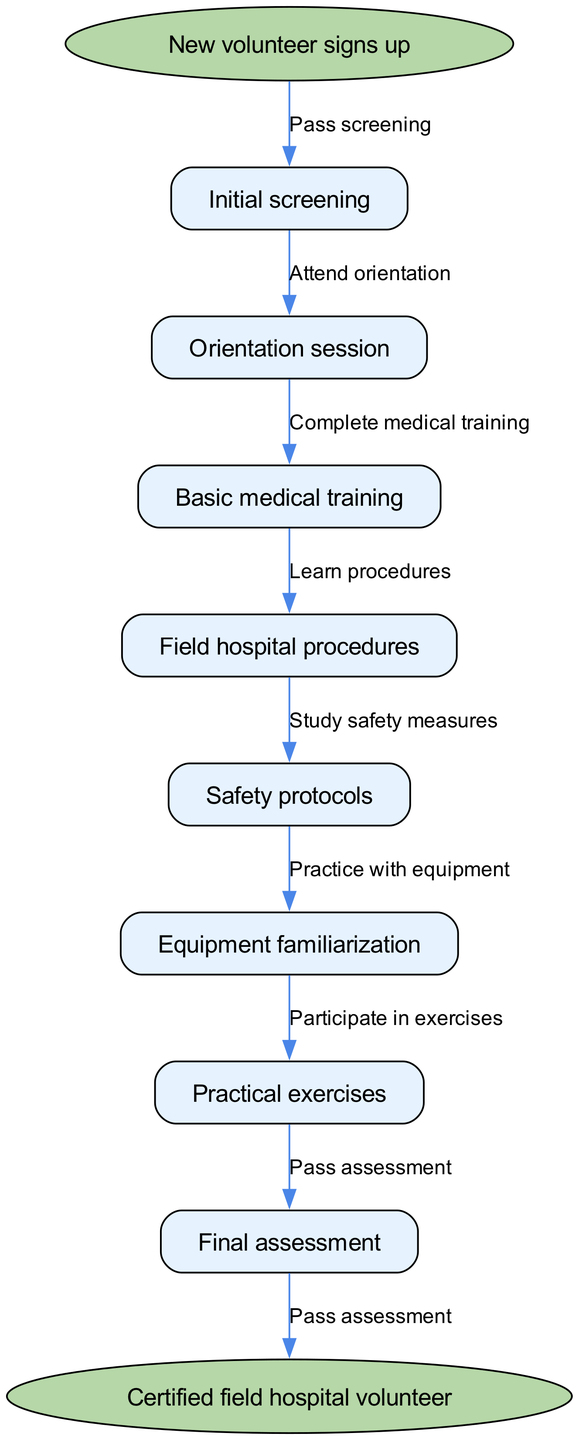What is the first step in the training workflow? The diagram begins with the "New volunteer signs up" step, which is the starting point of the workflow before moving to the first action.
Answer: New volunteer signs up How many nodes are there in the workflow? The diagram lists a total of 8 nodes, which include the initial screening, orientation session, and other training components before concluding with the final assessment.
Answer: 8 What is the final node in the diagram? The last step in the diagram leads to the "Certified field hospital volunteer," which denotes the completion of the training process for volunteers.
Answer: Certified field hospital volunteer What training follows the orientation session? After the orientation session, the next training component in the workflow is "Basic medical training," which is essential for volunteers before proceeding further.
Answer: Basic medical training What is the edge connecting "Practical exercises" to the end node? The edge linking "Practical exercises" to the end node indicates that upon passing the final assessment, volunteers achieve certification, completing the training cycle logically and clearly.
Answer: Pass assessment Which training stage involves safety measures? The diagram specifies that "Safety protocols" are a dedicated training stage, highlighting the importance of understanding safety in the field hospital environment.
Answer: Safety protocols What training must be completed before equipment familiarization? According to the flow of the diagram, volunteers must first complete the "Safety protocols" training prior to advancing to the "Equipment familiarization" stage.
Answer: Safety protocols Which node requires passing a screening? The flow chart clearly states that "Initial screening" is the first step that requires passing in order to progress to subsequent training phases.
Answer: Initial screening 